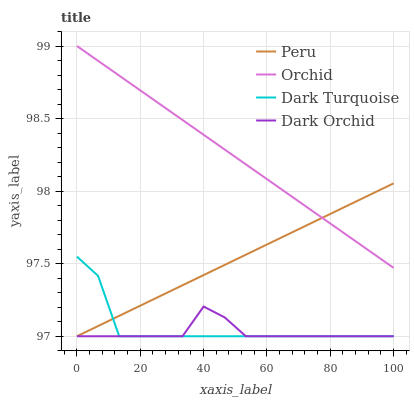Does Dark Orchid have the minimum area under the curve?
Answer yes or no. Yes. Does Orchid have the maximum area under the curve?
Answer yes or no. Yes. Does Peru have the minimum area under the curve?
Answer yes or no. No. Does Peru have the maximum area under the curve?
Answer yes or no. No. Is Orchid the smoothest?
Answer yes or no. Yes. Is Dark Turquoise the roughest?
Answer yes or no. Yes. Is Dark Orchid the smoothest?
Answer yes or no. No. Is Dark Orchid the roughest?
Answer yes or no. No. Does Dark Turquoise have the lowest value?
Answer yes or no. Yes. Does Orchid have the lowest value?
Answer yes or no. No. Does Orchid have the highest value?
Answer yes or no. Yes. Does Peru have the highest value?
Answer yes or no. No. Is Dark Orchid less than Orchid?
Answer yes or no. Yes. Is Orchid greater than Dark Orchid?
Answer yes or no. Yes. Does Dark Turquoise intersect Peru?
Answer yes or no. Yes. Is Dark Turquoise less than Peru?
Answer yes or no. No. Is Dark Turquoise greater than Peru?
Answer yes or no. No. Does Dark Orchid intersect Orchid?
Answer yes or no. No. 